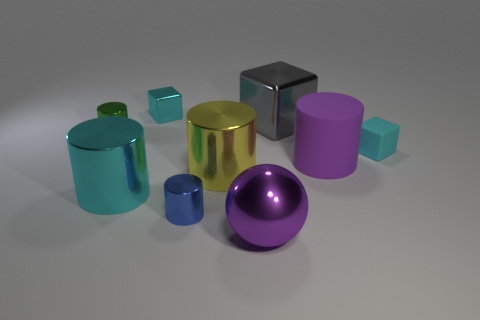The large thing left of the cyan metal thing behind the cyan metal cylinder is what color?
Provide a short and direct response. Cyan. What number of other objects are there of the same material as the sphere?
Offer a very short reply. 6. Is the number of cyan things that are on the right side of the rubber cylinder the same as the number of big gray shiny objects?
Offer a very short reply. Yes. There is a large cylinder that is on the left side of the tiny metallic thing that is in front of the tiny block in front of the tiny shiny block; what is its material?
Provide a short and direct response. Metal. What color is the cylinder that is right of the big metallic ball?
Make the answer very short. Purple. Are there any other things that are the same shape as the large gray thing?
Provide a succinct answer. Yes. There is a cyan shiny object in front of the cyan block behind the big block; what is its size?
Make the answer very short. Large. Is the number of purple rubber objects to the right of the yellow object the same as the number of large balls in front of the large purple ball?
Your answer should be very brief. No. Is there any other thing that is the same size as the cyan rubber block?
Keep it short and to the point. Yes. There is a big block that is made of the same material as the cyan cylinder; what color is it?
Your answer should be very brief. Gray. 